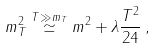<formula> <loc_0><loc_0><loc_500><loc_500>m _ { T } ^ { 2 } \stackrel { T \gg m _ { T } } { \simeq } m ^ { 2 } + \lambda \frac { T ^ { 2 } } { 2 4 } \, ,</formula> 